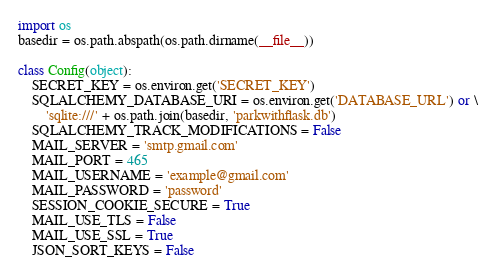<code> <loc_0><loc_0><loc_500><loc_500><_Python_>import os
basedir = os.path.abspath(os.path.dirname(__file__))

class Config(object):
    SECRET_KEY = os.environ.get('SECRET_KEY')
    SQLALCHEMY_DATABASE_URI = os.environ.get('DATABASE_URL') or \
        'sqlite:///' + os.path.join(basedir, 'parkwithflask.db')
    SQLALCHEMY_TRACK_MODIFICATIONS = False
    MAIL_SERVER = 'smtp.gmail.com'
    MAIL_PORT = 465
    MAIL_USERNAME = 'example@gmail.com'
    MAIL_PASSWORD = 'password'
    SESSION_COOKIE_SECURE = True
    MAIL_USE_TLS = False
    MAIL_USE_SSL = True
    JSON_SORT_KEYS = False
</code> 